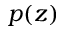<formula> <loc_0><loc_0><loc_500><loc_500>p ( z )</formula> 